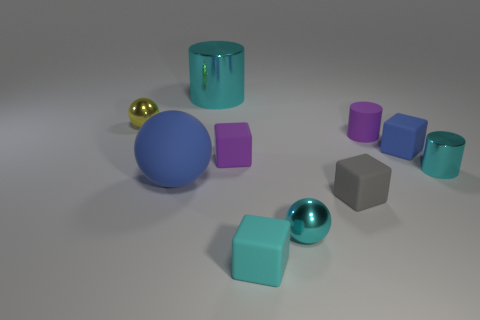Subtract all cylinders. How many objects are left? 7 Add 4 tiny purple matte objects. How many tiny purple matte objects are left? 6 Add 9 tiny purple metallic cylinders. How many tiny purple metallic cylinders exist? 9 Subtract 0 brown blocks. How many objects are left? 10 Subtract all green spheres. Subtract all blue matte cubes. How many objects are left? 9 